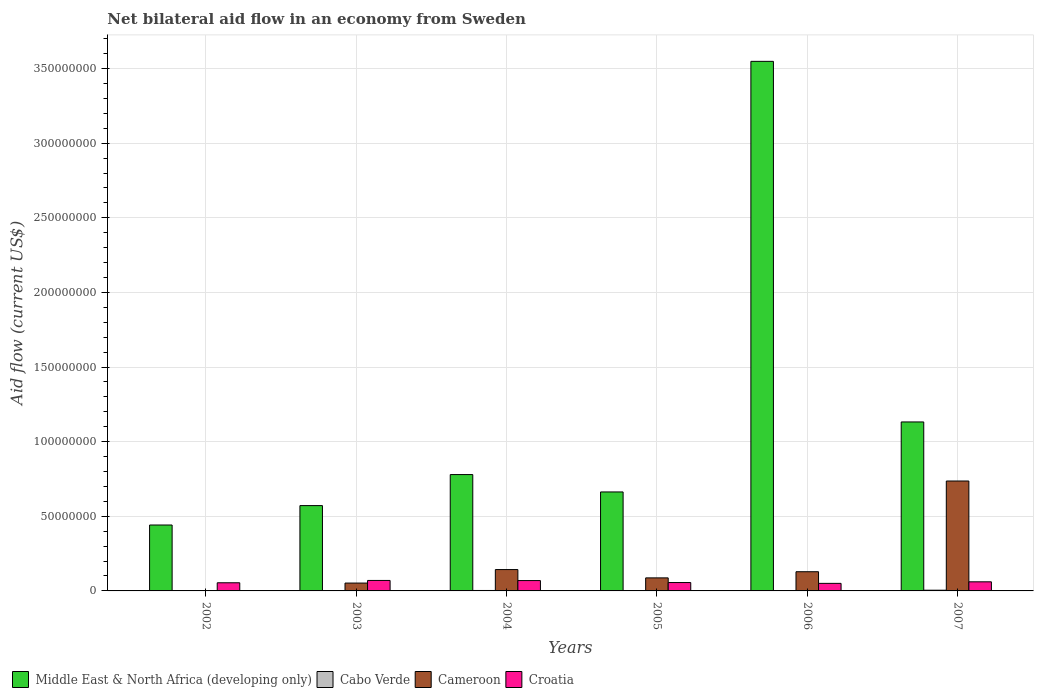How many different coloured bars are there?
Provide a succinct answer. 4. Are the number of bars per tick equal to the number of legend labels?
Provide a succinct answer. Yes. Are the number of bars on each tick of the X-axis equal?
Keep it short and to the point. Yes. What is the net bilateral aid flow in Cameroon in 2002?
Your response must be concise. 2.00e+04. Across all years, what is the maximum net bilateral aid flow in Cameroon?
Provide a succinct answer. 7.36e+07. In which year was the net bilateral aid flow in Croatia maximum?
Give a very brief answer. 2003. In which year was the net bilateral aid flow in Cameroon minimum?
Offer a terse response. 2002. What is the total net bilateral aid flow in Cabo Verde in the graph?
Keep it short and to the point. 1.27e+06. What is the difference between the net bilateral aid flow in Cameroon in 2002 and that in 2006?
Your answer should be very brief. -1.28e+07. What is the difference between the net bilateral aid flow in Middle East & North Africa (developing only) in 2007 and the net bilateral aid flow in Croatia in 2003?
Offer a terse response. 1.06e+08. What is the average net bilateral aid flow in Cabo Verde per year?
Your response must be concise. 2.12e+05. In the year 2002, what is the difference between the net bilateral aid flow in Middle East & North Africa (developing only) and net bilateral aid flow in Cabo Verde?
Keep it short and to the point. 4.41e+07. What is the ratio of the net bilateral aid flow in Middle East & North Africa (developing only) in 2003 to that in 2005?
Your answer should be compact. 0.86. Is the net bilateral aid flow in Cameroon in 2003 less than that in 2006?
Provide a short and direct response. Yes. Is the difference between the net bilateral aid flow in Middle East & North Africa (developing only) in 2002 and 2006 greater than the difference between the net bilateral aid flow in Cabo Verde in 2002 and 2006?
Your answer should be compact. No. What is the difference between the highest and the second highest net bilateral aid flow in Cameroon?
Keep it short and to the point. 5.93e+07. What is the difference between the highest and the lowest net bilateral aid flow in Croatia?
Provide a succinct answer. 1.96e+06. In how many years, is the net bilateral aid flow in Croatia greater than the average net bilateral aid flow in Croatia taken over all years?
Make the answer very short. 3. Is it the case that in every year, the sum of the net bilateral aid flow in Middle East & North Africa (developing only) and net bilateral aid flow in Cabo Verde is greater than the sum of net bilateral aid flow in Croatia and net bilateral aid flow in Cameroon?
Provide a short and direct response. Yes. What does the 3rd bar from the left in 2004 represents?
Offer a very short reply. Cameroon. What does the 3rd bar from the right in 2004 represents?
Your answer should be compact. Cabo Verde. How many bars are there?
Provide a short and direct response. 24. How many years are there in the graph?
Give a very brief answer. 6. Are the values on the major ticks of Y-axis written in scientific E-notation?
Provide a succinct answer. No. Does the graph contain any zero values?
Provide a short and direct response. No. Does the graph contain grids?
Make the answer very short. Yes. How many legend labels are there?
Your response must be concise. 4. How are the legend labels stacked?
Offer a terse response. Horizontal. What is the title of the graph?
Provide a succinct answer. Net bilateral aid flow in an economy from Sweden. What is the label or title of the Y-axis?
Offer a very short reply. Aid flow (current US$). What is the Aid flow (current US$) of Middle East & North Africa (developing only) in 2002?
Ensure brevity in your answer.  4.42e+07. What is the Aid flow (current US$) of Cabo Verde in 2002?
Make the answer very short. 6.00e+04. What is the Aid flow (current US$) in Cameroon in 2002?
Offer a terse response. 2.00e+04. What is the Aid flow (current US$) in Croatia in 2002?
Make the answer very short. 5.46e+06. What is the Aid flow (current US$) of Middle East & North Africa (developing only) in 2003?
Give a very brief answer. 5.72e+07. What is the Aid flow (current US$) in Cameroon in 2003?
Offer a very short reply. 5.26e+06. What is the Aid flow (current US$) of Croatia in 2003?
Your response must be concise. 7.02e+06. What is the Aid flow (current US$) in Middle East & North Africa (developing only) in 2004?
Keep it short and to the point. 7.80e+07. What is the Aid flow (current US$) in Cameroon in 2004?
Ensure brevity in your answer.  1.43e+07. What is the Aid flow (current US$) of Croatia in 2004?
Your answer should be compact. 6.93e+06. What is the Aid flow (current US$) in Middle East & North Africa (developing only) in 2005?
Offer a terse response. 6.63e+07. What is the Aid flow (current US$) in Cabo Verde in 2005?
Give a very brief answer. 2.00e+05. What is the Aid flow (current US$) in Cameroon in 2005?
Make the answer very short. 8.74e+06. What is the Aid flow (current US$) of Croatia in 2005?
Offer a very short reply. 5.62e+06. What is the Aid flow (current US$) of Middle East & North Africa (developing only) in 2006?
Offer a very short reply. 3.55e+08. What is the Aid flow (current US$) of Cabo Verde in 2006?
Your answer should be very brief. 1.50e+05. What is the Aid flow (current US$) of Cameroon in 2006?
Your answer should be compact. 1.29e+07. What is the Aid flow (current US$) of Croatia in 2006?
Ensure brevity in your answer.  5.06e+06. What is the Aid flow (current US$) in Middle East & North Africa (developing only) in 2007?
Offer a terse response. 1.13e+08. What is the Aid flow (current US$) in Cabo Verde in 2007?
Make the answer very short. 4.80e+05. What is the Aid flow (current US$) of Cameroon in 2007?
Offer a terse response. 7.36e+07. What is the Aid flow (current US$) of Croatia in 2007?
Make the answer very short. 6.10e+06. Across all years, what is the maximum Aid flow (current US$) of Middle East & North Africa (developing only)?
Offer a very short reply. 3.55e+08. Across all years, what is the maximum Aid flow (current US$) in Cabo Verde?
Make the answer very short. 4.80e+05. Across all years, what is the maximum Aid flow (current US$) in Cameroon?
Your answer should be very brief. 7.36e+07. Across all years, what is the maximum Aid flow (current US$) in Croatia?
Your answer should be very brief. 7.02e+06. Across all years, what is the minimum Aid flow (current US$) of Middle East & North Africa (developing only)?
Ensure brevity in your answer.  4.42e+07. Across all years, what is the minimum Aid flow (current US$) of Cabo Verde?
Your answer should be very brief. 6.00e+04. Across all years, what is the minimum Aid flow (current US$) of Croatia?
Provide a succinct answer. 5.06e+06. What is the total Aid flow (current US$) in Middle East & North Africa (developing only) in the graph?
Your answer should be compact. 7.14e+08. What is the total Aid flow (current US$) of Cabo Verde in the graph?
Provide a short and direct response. 1.27e+06. What is the total Aid flow (current US$) in Cameroon in the graph?
Make the answer very short. 1.15e+08. What is the total Aid flow (current US$) in Croatia in the graph?
Make the answer very short. 3.62e+07. What is the difference between the Aid flow (current US$) of Middle East & North Africa (developing only) in 2002 and that in 2003?
Offer a very short reply. -1.30e+07. What is the difference between the Aid flow (current US$) of Cabo Verde in 2002 and that in 2003?
Give a very brief answer. -2.00e+04. What is the difference between the Aid flow (current US$) of Cameroon in 2002 and that in 2003?
Offer a very short reply. -5.24e+06. What is the difference between the Aid flow (current US$) of Croatia in 2002 and that in 2003?
Ensure brevity in your answer.  -1.56e+06. What is the difference between the Aid flow (current US$) in Middle East & North Africa (developing only) in 2002 and that in 2004?
Ensure brevity in your answer.  -3.38e+07. What is the difference between the Aid flow (current US$) in Cameroon in 2002 and that in 2004?
Ensure brevity in your answer.  -1.43e+07. What is the difference between the Aid flow (current US$) of Croatia in 2002 and that in 2004?
Make the answer very short. -1.47e+06. What is the difference between the Aid flow (current US$) of Middle East & North Africa (developing only) in 2002 and that in 2005?
Your answer should be very brief. -2.22e+07. What is the difference between the Aid flow (current US$) of Cabo Verde in 2002 and that in 2005?
Make the answer very short. -1.40e+05. What is the difference between the Aid flow (current US$) of Cameroon in 2002 and that in 2005?
Give a very brief answer. -8.72e+06. What is the difference between the Aid flow (current US$) of Middle East & North Africa (developing only) in 2002 and that in 2006?
Offer a very short reply. -3.11e+08. What is the difference between the Aid flow (current US$) of Cabo Verde in 2002 and that in 2006?
Keep it short and to the point. -9.00e+04. What is the difference between the Aid flow (current US$) in Cameroon in 2002 and that in 2006?
Offer a terse response. -1.28e+07. What is the difference between the Aid flow (current US$) of Croatia in 2002 and that in 2006?
Ensure brevity in your answer.  4.00e+05. What is the difference between the Aid flow (current US$) of Middle East & North Africa (developing only) in 2002 and that in 2007?
Your answer should be very brief. -6.90e+07. What is the difference between the Aid flow (current US$) of Cabo Verde in 2002 and that in 2007?
Give a very brief answer. -4.20e+05. What is the difference between the Aid flow (current US$) of Cameroon in 2002 and that in 2007?
Provide a succinct answer. -7.36e+07. What is the difference between the Aid flow (current US$) of Croatia in 2002 and that in 2007?
Provide a succinct answer. -6.40e+05. What is the difference between the Aid flow (current US$) in Middle East & North Africa (developing only) in 2003 and that in 2004?
Your answer should be very brief. -2.08e+07. What is the difference between the Aid flow (current US$) in Cameroon in 2003 and that in 2004?
Provide a short and direct response. -9.05e+06. What is the difference between the Aid flow (current US$) of Middle East & North Africa (developing only) in 2003 and that in 2005?
Your answer should be very brief. -9.15e+06. What is the difference between the Aid flow (current US$) of Cabo Verde in 2003 and that in 2005?
Give a very brief answer. -1.20e+05. What is the difference between the Aid flow (current US$) of Cameroon in 2003 and that in 2005?
Give a very brief answer. -3.48e+06. What is the difference between the Aid flow (current US$) of Croatia in 2003 and that in 2005?
Your answer should be compact. 1.40e+06. What is the difference between the Aid flow (current US$) in Middle East & North Africa (developing only) in 2003 and that in 2006?
Keep it short and to the point. -2.98e+08. What is the difference between the Aid flow (current US$) in Cameroon in 2003 and that in 2006?
Your answer should be compact. -7.60e+06. What is the difference between the Aid flow (current US$) of Croatia in 2003 and that in 2006?
Ensure brevity in your answer.  1.96e+06. What is the difference between the Aid flow (current US$) of Middle East & North Africa (developing only) in 2003 and that in 2007?
Make the answer very short. -5.60e+07. What is the difference between the Aid flow (current US$) in Cabo Verde in 2003 and that in 2007?
Make the answer very short. -4.00e+05. What is the difference between the Aid flow (current US$) in Cameroon in 2003 and that in 2007?
Offer a terse response. -6.84e+07. What is the difference between the Aid flow (current US$) of Croatia in 2003 and that in 2007?
Your response must be concise. 9.20e+05. What is the difference between the Aid flow (current US$) in Middle East & North Africa (developing only) in 2004 and that in 2005?
Your answer should be compact. 1.16e+07. What is the difference between the Aid flow (current US$) of Cabo Verde in 2004 and that in 2005?
Your response must be concise. 1.00e+05. What is the difference between the Aid flow (current US$) in Cameroon in 2004 and that in 2005?
Give a very brief answer. 5.57e+06. What is the difference between the Aid flow (current US$) of Croatia in 2004 and that in 2005?
Provide a short and direct response. 1.31e+06. What is the difference between the Aid flow (current US$) of Middle East & North Africa (developing only) in 2004 and that in 2006?
Provide a succinct answer. -2.77e+08. What is the difference between the Aid flow (current US$) in Cabo Verde in 2004 and that in 2006?
Your answer should be very brief. 1.50e+05. What is the difference between the Aid flow (current US$) in Cameroon in 2004 and that in 2006?
Offer a terse response. 1.45e+06. What is the difference between the Aid flow (current US$) in Croatia in 2004 and that in 2006?
Your answer should be very brief. 1.87e+06. What is the difference between the Aid flow (current US$) of Middle East & North Africa (developing only) in 2004 and that in 2007?
Your answer should be very brief. -3.52e+07. What is the difference between the Aid flow (current US$) of Cameroon in 2004 and that in 2007?
Your answer should be very brief. -5.93e+07. What is the difference between the Aid flow (current US$) in Croatia in 2004 and that in 2007?
Keep it short and to the point. 8.30e+05. What is the difference between the Aid flow (current US$) in Middle East & North Africa (developing only) in 2005 and that in 2006?
Your response must be concise. -2.88e+08. What is the difference between the Aid flow (current US$) of Cameroon in 2005 and that in 2006?
Provide a succinct answer. -4.12e+06. What is the difference between the Aid flow (current US$) of Croatia in 2005 and that in 2006?
Provide a succinct answer. 5.60e+05. What is the difference between the Aid flow (current US$) of Middle East & North Africa (developing only) in 2005 and that in 2007?
Provide a short and direct response. -4.69e+07. What is the difference between the Aid flow (current US$) of Cabo Verde in 2005 and that in 2007?
Provide a succinct answer. -2.80e+05. What is the difference between the Aid flow (current US$) in Cameroon in 2005 and that in 2007?
Keep it short and to the point. -6.49e+07. What is the difference between the Aid flow (current US$) in Croatia in 2005 and that in 2007?
Offer a terse response. -4.80e+05. What is the difference between the Aid flow (current US$) of Middle East & North Africa (developing only) in 2006 and that in 2007?
Your answer should be compact. 2.42e+08. What is the difference between the Aid flow (current US$) of Cabo Verde in 2006 and that in 2007?
Keep it short and to the point. -3.30e+05. What is the difference between the Aid flow (current US$) in Cameroon in 2006 and that in 2007?
Your response must be concise. -6.08e+07. What is the difference between the Aid flow (current US$) of Croatia in 2006 and that in 2007?
Keep it short and to the point. -1.04e+06. What is the difference between the Aid flow (current US$) in Middle East & North Africa (developing only) in 2002 and the Aid flow (current US$) in Cabo Verde in 2003?
Give a very brief answer. 4.41e+07. What is the difference between the Aid flow (current US$) of Middle East & North Africa (developing only) in 2002 and the Aid flow (current US$) of Cameroon in 2003?
Your response must be concise. 3.89e+07. What is the difference between the Aid flow (current US$) of Middle East & North Africa (developing only) in 2002 and the Aid flow (current US$) of Croatia in 2003?
Make the answer very short. 3.71e+07. What is the difference between the Aid flow (current US$) of Cabo Verde in 2002 and the Aid flow (current US$) of Cameroon in 2003?
Provide a succinct answer. -5.20e+06. What is the difference between the Aid flow (current US$) in Cabo Verde in 2002 and the Aid flow (current US$) in Croatia in 2003?
Provide a succinct answer. -6.96e+06. What is the difference between the Aid flow (current US$) in Cameroon in 2002 and the Aid flow (current US$) in Croatia in 2003?
Give a very brief answer. -7.00e+06. What is the difference between the Aid flow (current US$) in Middle East & North Africa (developing only) in 2002 and the Aid flow (current US$) in Cabo Verde in 2004?
Your answer should be compact. 4.39e+07. What is the difference between the Aid flow (current US$) of Middle East & North Africa (developing only) in 2002 and the Aid flow (current US$) of Cameroon in 2004?
Your answer should be very brief. 2.98e+07. What is the difference between the Aid flow (current US$) of Middle East & North Africa (developing only) in 2002 and the Aid flow (current US$) of Croatia in 2004?
Your response must be concise. 3.72e+07. What is the difference between the Aid flow (current US$) in Cabo Verde in 2002 and the Aid flow (current US$) in Cameroon in 2004?
Provide a succinct answer. -1.42e+07. What is the difference between the Aid flow (current US$) of Cabo Verde in 2002 and the Aid flow (current US$) of Croatia in 2004?
Give a very brief answer. -6.87e+06. What is the difference between the Aid flow (current US$) in Cameroon in 2002 and the Aid flow (current US$) in Croatia in 2004?
Make the answer very short. -6.91e+06. What is the difference between the Aid flow (current US$) of Middle East & North Africa (developing only) in 2002 and the Aid flow (current US$) of Cabo Verde in 2005?
Your answer should be very brief. 4.40e+07. What is the difference between the Aid flow (current US$) in Middle East & North Africa (developing only) in 2002 and the Aid flow (current US$) in Cameroon in 2005?
Make the answer very short. 3.54e+07. What is the difference between the Aid flow (current US$) of Middle East & North Africa (developing only) in 2002 and the Aid flow (current US$) of Croatia in 2005?
Ensure brevity in your answer.  3.85e+07. What is the difference between the Aid flow (current US$) in Cabo Verde in 2002 and the Aid flow (current US$) in Cameroon in 2005?
Offer a terse response. -8.68e+06. What is the difference between the Aid flow (current US$) of Cabo Verde in 2002 and the Aid flow (current US$) of Croatia in 2005?
Give a very brief answer. -5.56e+06. What is the difference between the Aid flow (current US$) in Cameroon in 2002 and the Aid flow (current US$) in Croatia in 2005?
Provide a succinct answer. -5.60e+06. What is the difference between the Aid flow (current US$) in Middle East & North Africa (developing only) in 2002 and the Aid flow (current US$) in Cabo Verde in 2006?
Offer a very short reply. 4.40e+07. What is the difference between the Aid flow (current US$) of Middle East & North Africa (developing only) in 2002 and the Aid flow (current US$) of Cameroon in 2006?
Make the answer very short. 3.13e+07. What is the difference between the Aid flow (current US$) of Middle East & North Africa (developing only) in 2002 and the Aid flow (current US$) of Croatia in 2006?
Provide a short and direct response. 3.91e+07. What is the difference between the Aid flow (current US$) of Cabo Verde in 2002 and the Aid flow (current US$) of Cameroon in 2006?
Your answer should be very brief. -1.28e+07. What is the difference between the Aid flow (current US$) of Cabo Verde in 2002 and the Aid flow (current US$) of Croatia in 2006?
Ensure brevity in your answer.  -5.00e+06. What is the difference between the Aid flow (current US$) of Cameroon in 2002 and the Aid flow (current US$) of Croatia in 2006?
Provide a succinct answer. -5.04e+06. What is the difference between the Aid flow (current US$) in Middle East & North Africa (developing only) in 2002 and the Aid flow (current US$) in Cabo Verde in 2007?
Your answer should be very brief. 4.37e+07. What is the difference between the Aid flow (current US$) in Middle East & North Africa (developing only) in 2002 and the Aid flow (current US$) in Cameroon in 2007?
Your answer should be very brief. -2.95e+07. What is the difference between the Aid flow (current US$) of Middle East & North Africa (developing only) in 2002 and the Aid flow (current US$) of Croatia in 2007?
Ensure brevity in your answer.  3.81e+07. What is the difference between the Aid flow (current US$) in Cabo Verde in 2002 and the Aid flow (current US$) in Cameroon in 2007?
Keep it short and to the point. -7.36e+07. What is the difference between the Aid flow (current US$) of Cabo Verde in 2002 and the Aid flow (current US$) of Croatia in 2007?
Offer a terse response. -6.04e+06. What is the difference between the Aid flow (current US$) in Cameroon in 2002 and the Aid flow (current US$) in Croatia in 2007?
Provide a short and direct response. -6.08e+06. What is the difference between the Aid flow (current US$) of Middle East & North Africa (developing only) in 2003 and the Aid flow (current US$) of Cabo Verde in 2004?
Give a very brief answer. 5.69e+07. What is the difference between the Aid flow (current US$) in Middle East & North Africa (developing only) in 2003 and the Aid flow (current US$) in Cameroon in 2004?
Offer a very short reply. 4.28e+07. What is the difference between the Aid flow (current US$) of Middle East & North Africa (developing only) in 2003 and the Aid flow (current US$) of Croatia in 2004?
Your response must be concise. 5.02e+07. What is the difference between the Aid flow (current US$) in Cabo Verde in 2003 and the Aid flow (current US$) in Cameroon in 2004?
Give a very brief answer. -1.42e+07. What is the difference between the Aid flow (current US$) of Cabo Verde in 2003 and the Aid flow (current US$) of Croatia in 2004?
Your answer should be compact. -6.85e+06. What is the difference between the Aid flow (current US$) of Cameroon in 2003 and the Aid flow (current US$) of Croatia in 2004?
Offer a very short reply. -1.67e+06. What is the difference between the Aid flow (current US$) in Middle East & North Africa (developing only) in 2003 and the Aid flow (current US$) in Cabo Verde in 2005?
Give a very brief answer. 5.70e+07. What is the difference between the Aid flow (current US$) of Middle East & North Africa (developing only) in 2003 and the Aid flow (current US$) of Cameroon in 2005?
Give a very brief answer. 4.84e+07. What is the difference between the Aid flow (current US$) of Middle East & North Africa (developing only) in 2003 and the Aid flow (current US$) of Croatia in 2005?
Provide a short and direct response. 5.15e+07. What is the difference between the Aid flow (current US$) in Cabo Verde in 2003 and the Aid flow (current US$) in Cameroon in 2005?
Offer a terse response. -8.66e+06. What is the difference between the Aid flow (current US$) of Cabo Verde in 2003 and the Aid flow (current US$) of Croatia in 2005?
Provide a short and direct response. -5.54e+06. What is the difference between the Aid flow (current US$) in Cameroon in 2003 and the Aid flow (current US$) in Croatia in 2005?
Your response must be concise. -3.60e+05. What is the difference between the Aid flow (current US$) of Middle East & North Africa (developing only) in 2003 and the Aid flow (current US$) of Cabo Verde in 2006?
Keep it short and to the point. 5.70e+07. What is the difference between the Aid flow (current US$) in Middle East & North Africa (developing only) in 2003 and the Aid flow (current US$) in Cameroon in 2006?
Keep it short and to the point. 4.43e+07. What is the difference between the Aid flow (current US$) of Middle East & North Africa (developing only) in 2003 and the Aid flow (current US$) of Croatia in 2006?
Your answer should be very brief. 5.21e+07. What is the difference between the Aid flow (current US$) in Cabo Verde in 2003 and the Aid flow (current US$) in Cameroon in 2006?
Provide a succinct answer. -1.28e+07. What is the difference between the Aid flow (current US$) of Cabo Verde in 2003 and the Aid flow (current US$) of Croatia in 2006?
Make the answer very short. -4.98e+06. What is the difference between the Aid flow (current US$) of Middle East & North Africa (developing only) in 2003 and the Aid flow (current US$) of Cabo Verde in 2007?
Provide a succinct answer. 5.67e+07. What is the difference between the Aid flow (current US$) of Middle East & North Africa (developing only) in 2003 and the Aid flow (current US$) of Cameroon in 2007?
Provide a succinct answer. -1.65e+07. What is the difference between the Aid flow (current US$) of Middle East & North Africa (developing only) in 2003 and the Aid flow (current US$) of Croatia in 2007?
Make the answer very short. 5.11e+07. What is the difference between the Aid flow (current US$) of Cabo Verde in 2003 and the Aid flow (current US$) of Cameroon in 2007?
Keep it short and to the point. -7.36e+07. What is the difference between the Aid flow (current US$) in Cabo Verde in 2003 and the Aid flow (current US$) in Croatia in 2007?
Offer a terse response. -6.02e+06. What is the difference between the Aid flow (current US$) in Cameroon in 2003 and the Aid flow (current US$) in Croatia in 2007?
Ensure brevity in your answer.  -8.40e+05. What is the difference between the Aid flow (current US$) in Middle East & North Africa (developing only) in 2004 and the Aid flow (current US$) in Cabo Verde in 2005?
Offer a very short reply. 7.78e+07. What is the difference between the Aid flow (current US$) of Middle East & North Africa (developing only) in 2004 and the Aid flow (current US$) of Cameroon in 2005?
Make the answer very short. 6.92e+07. What is the difference between the Aid flow (current US$) of Middle East & North Africa (developing only) in 2004 and the Aid flow (current US$) of Croatia in 2005?
Make the answer very short. 7.23e+07. What is the difference between the Aid flow (current US$) of Cabo Verde in 2004 and the Aid flow (current US$) of Cameroon in 2005?
Offer a terse response. -8.44e+06. What is the difference between the Aid flow (current US$) of Cabo Verde in 2004 and the Aid flow (current US$) of Croatia in 2005?
Give a very brief answer. -5.32e+06. What is the difference between the Aid flow (current US$) in Cameroon in 2004 and the Aid flow (current US$) in Croatia in 2005?
Offer a terse response. 8.69e+06. What is the difference between the Aid flow (current US$) in Middle East & North Africa (developing only) in 2004 and the Aid flow (current US$) in Cabo Verde in 2006?
Offer a terse response. 7.78e+07. What is the difference between the Aid flow (current US$) in Middle East & North Africa (developing only) in 2004 and the Aid flow (current US$) in Cameroon in 2006?
Make the answer very short. 6.51e+07. What is the difference between the Aid flow (current US$) of Middle East & North Africa (developing only) in 2004 and the Aid flow (current US$) of Croatia in 2006?
Make the answer very short. 7.29e+07. What is the difference between the Aid flow (current US$) in Cabo Verde in 2004 and the Aid flow (current US$) in Cameroon in 2006?
Provide a succinct answer. -1.26e+07. What is the difference between the Aid flow (current US$) in Cabo Verde in 2004 and the Aid flow (current US$) in Croatia in 2006?
Your answer should be compact. -4.76e+06. What is the difference between the Aid flow (current US$) in Cameroon in 2004 and the Aid flow (current US$) in Croatia in 2006?
Your answer should be very brief. 9.25e+06. What is the difference between the Aid flow (current US$) in Middle East & North Africa (developing only) in 2004 and the Aid flow (current US$) in Cabo Verde in 2007?
Your answer should be very brief. 7.75e+07. What is the difference between the Aid flow (current US$) in Middle East & North Africa (developing only) in 2004 and the Aid flow (current US$) in Cameroon in 2007?
Offer a very short reply. 4.32e+06. What is the difference between the Aid flow (current US$) in Middle East & North Africa (developing only) in 2004 and the Aid flow (current US$) in Croatia in 2007?
Ensure brevity in your answer.  7.19e+07. What is the difference between the Aid flow (current US$) in Cabo Verde in 2004 and the Aid flow (current US$) in Cameroon in 2007?
Make the answer very short. -7.33e+07. What is the difference between the Aid flow (current US$) in Cabo Verde in 2004 and the Aid flow (current US$) in Croatia in 2007?
Provide a succinct answer. -5.80e+06. What is the difference between the Aid flow (current US$) in Cameroon in 2004 and the Aid flow (current US$) in Croatia in 2007?
Ensure brevity in your answer.  8.21e+06. What is the difference between the Aid flow (current US$) of Middle East & North Africa (developing only) in 2005 and the Aid flow (current US$) of Cabo Verde in 2006?
Give a very brief answer. 6.62e+07. What is the difference between the Aid flow (current US$) of Middle East & North Africa (developing only) in 2005 and the Aid flow (current US$) of Cameroon in 2006?
Make the answer very short. 5.34e+07. What is the difference between the Aid flow (current US$) of Middle East & North Africa (developing only) in 2005 and the Aid flow (current US$) of Croatia in 2006?
Offer a terse response. 6.12e+07. What is the difference between the Aid flow (current US$) of Cabo Verde in 2005 and the Aid flow (current US$) of Cameroon in 2006?
Provide a succinct answer. -1.27e+07. What is the difference between the Aid flow (current US$) of Cabo Verde in 2005 and the Aid flow (current US$) of Croatia in 2006?
Keep it short and to the point. -4.86e+06. What is the difference between the Aid flow (current US$) of Cameroon in 2005 and the Aid flow (current US$) of Croatia in 2006?
Offer a very short reply. 3.68e+06. What is the difference between the Aid flow (current US$) in Middle East & North Africa (developing only) in 2005 and the Aid flow (current US$) in Cabo Verde in 2007?
Offer a terse response. 6.58e+07. What is the difference between the Aid flow (current US$) of Middle East & North Africa (developing only) in 2005 and the Aid flow (current US$) of Cameroon in 2007?
Your answer should be very brief. -7.33e+06. What is the difference between the Aid flow (current US$) of Middle East & North Africa (developing only) in 2005 and the Aid flow (current US$) of Croatia in 2007?
Your answer should be very brief. 6.02e+07. What is the difference between the Aid flow (current US$) of Cabo Verde in 2005 and the Aid flow (current US$) of Cameroon in 2007?
Make the answer very short. -7.34e+07. What is the difference between the Aid flow (current US$) in Cabo Verde in 2005 and the Aid flow (current US$) in Croatia in 2007?
Your answer should be very brief. -5.90e+06. What is the difference between the Aid flow (current US$) of Cameroon in 2005 and the Aid flow (current US$) of Croatia in 2007?
Give a very brief answer. 2.64e+06. What is the difference between the Aid flow (current US$) in Middle East & North Africa (developing only) in 2006 and the Aid flow (current US$) in Cabo Verde in 2007?
Keep it short and to the point. 3.54e+08. What is the difference between the Aid flow (current US$) of Middle East & North Africa (developing only) in 2006 and the Aid flow (current US$) of Cameroon in 2007?
Provide a succinct answer. 2.81e+08. What is the difference between the Aid flow (current US$) of Middle East & North Africa (developing only) in 2006 and the Aid flow (current US$) of Croatia in 2007?
Ensure brevity in your answer.  3.49e+08. What is the difference between the Aid flow (current US$) in Cabo Verde in 2006 and the Aid flow (current US$) in Cameroon in 2007?
Ensure brevity in your answer.  -7.35e+07. What is the difference between the Aid flow (current US$) of Cabo Verde in 2006 and the Aid flow (current US$) of Croatia in 2007?
Ensure brevity in your answer.  -5.95e+06. What is the difference between the Aid flow (current US$) in Cameroon in 2006 and the Aid flow (current US$) in Croatia in 2007?
Make the answer very short. 6.76e+06. What is the average Aid flow (current US$) of Middle East & North Africa (developing only) per year?
Your response must be concise. 1.19e+08. What is the average Aid flow (current US$) of Cabo Verde per year?
Make the answer very short. 2.12e+05. What is the average Aid flow (current US$) of Cameroon per year?
Offer a very short reply. 1.91e+07. What is the average Aid flow (current US$) in Croatia per year?
Make the answer very short. 6.03e+06. In the year 2002, what is the difference between the Aid flow (current US$) in Middle East & North Africa (developing only) and Aid flow (current US$) in Cabo Verde?
Provide a short and direct response. 4.41e+07. In the year 2002, what is the difference between the Aid flow (current US$) in Middle East & North Africa (developing only) and Aid flow (current US$) in Cameroon?
Provide a short and direct response. 4.41e+07. In the year 2002, what is the difference between the Aid flow (current US$) of Middle East & North Africa (developing only) and Aid flow (current US$) of Croatia?
Offer a terse response. 3.87e+07. In the year 2002, what is the difference between the Aid flow (current US$) in Cabo Verde and Aid flow (current US$) in Cameroon?
Your answer should be very brief. 4.00e+04. In the year 2002, what is the difference between the Aid flow (current US$) of Cabo Verde and Aid flow (current US$) of Croatia?
Provide a succinct answer. -5.40e+06. In the year 2002, what is the difference between the Aid flow (current US$) of Cameroon and Aid flow (current US$) of Croatia?
Provide a short and direct response. -5.44e+06. In the year 2003, what is the difference between the Aid flow (current US$) in Middle East & North Africa (developing only) and Aid flow (current US$) in Cabo Verde?
Your answer should be very brief. 5.71e+07. In the year 2003, what is the difference between the Aid flow (current US$) in Middle East & North Africa (developing only) and Aid flow (current US$) in Cameroon?
Offer a very short reply. 5.19e+07. In the year 2003, what is the difference between the Aid flow (current US$) in Middle East & North Africa (developing only) and Aid flow (current US$) in Croatia?
Keep it short and to the point. 5.01e+07. In the year 2003, what is the difference between the Aid flow (current US$) in Cabo Verde and Aid flow (current US$) in Cameroon?
Your answer should be compact. -5.18e+06. In the year 2003, what is the difference between the Aid flow (current US$) of Cabo Verde and Aid flow (current US$) of Croatia?
Your response must be concise. -6.94e+06. In the year 2003, what is the difference between the Aid flow (current US$) of Cameroon and Aid flow (current US$) of Croatia?
Your response must be concise. -1.76e+06. In the year 2004, what is the difference between the Aid flow (current US$) of Middle East & North Africa (developing only) and Aid flow (current US$) of Cabo Verde?
Provide a succinct answer. 7.77e+07. In the year 2004, what is the difference between the Aid flow (current US$) of Middle East & North Africa (developing only) and Aid flow (current US$) of Cameroon?
Provide a succinct answer. 6.36e+07. In the year 2004, what is the difference between the Aid flow (current US$) in Middle East & North Africa (developing only) and Aid flow (current US$) in Croatia?
Offer a very short reply. 7.10e+07. In the year 2004, what is the difference between the Aid flow (current US$) in Cabo Verde and Aid flow (current US$) in Cameroon?
Your answer should be compact. -1.40e+07. In the year 2004, what is the difference between the Aid flow (current US$) of Cabo Verde and Aid flow (current US$) of Croatia?
Your answer should be very brief. -6.63e+06. In the year 2004, what is the difference between the Aid flow (current US$) in Cameroon and Aid flow (current US$) in Croatia?
Your answer should be very brief. 7.38e+06. In the year 2005, what is the difference between the Aid flow (current US$) of Middle East & North Africa (developing only) and Aid flow (current US$) of Cabo Verde?
Make the answer very short. 6.61e+07. In the year 2005, what is the difference between the Aid flow (current US$) of Middle East & North Africa (developing only) and Aid flow (current US$) of Cameroon?
Give a very brief answer. 5.76e+07. In the year 2005, what is the difference between the Aid flow (current US$) of Middle East & North Africa (developing only) and Aid flow (current US$) of Croatia?
Offer a terse response. 6.07e+07. In the year 2005, what is the difference between the Aid flow (current US$) in Cabo Verde and Aid flow (current US$) in Cameroon?
Your answer should be compact. -8.54e+06. In the year 2005, what is the difference between the Aid flow (current US$) in Cabo Verde and Aid flow (current US$) in Croatia?
Your answer should be compact. -5.42e+06. In the year 2005, what is the difference between the Aid flow (current US$) of Cameroon and Aid flow (current US$) of Croatia?
Your answer should be very brief. 3.12e+06. In the year 2006, what is the difference between the Aid flow (current US$) in Middle East & North Africa (developing only) and Aid flow (current US$) in Cabo Verde?
Your answer should be very brief. 3.55e+08. In the year 2006, what is the difference between the Aid flow (current US$) in Middle East & North Africa (developing only) and Aid flow (current US$) in Cameroon?
Provide a succinct answer. 3.42e+08. In the year 2006, what is the difference between the Aid flow (current US$) of Middle East & North Africa (developing only) and Aid flow (current US$) of Croatia?
Ensure brevity in your answer.  3.50e+08. In the year 2006, what is the difference between the Aid flow (current US$) in Cabo Verde and Aid flow (current US$) in Cameroon?
Provide a short and direct response. -1.27e+07. In the year 2006, what is the difference between the Aid flow (current US$) in Cabo Verde and Aid flow (current US$) in Croatia?
Your response must be concise. -4.91e+06. In the year 2006, what is the difference between the Aid flow (current US$) of Cameroon and Aid flow (current US$) of Croatia?
Your answer should be very brief. 7.80e+06. In the year 2007, what is the difference between the Aid flow (current US$) in Middle East & North Africa (developing only) and Aid flow (current US$) in Cabo Verde?
Your answer should be very brief. 1.13e+08. In the year 2007, what is the difference between the Aid flow (current US$) of Middle East & North Africa (developing only) and Aid flow (current US$) of Cameroon?
Provide a short and direct response. 3.96e+07. In the year 2007, what is the difference between the Aid flow (current US$) of Middle East & North Africa (developing only) and Aid flow (current US$) of Croatia?
Provide a short and direct response. 1.07e+08. In the year 2007, what is the difference between the Aid flow (current US$) of Cabo Verde and Aid flow (current US$) of Cameroon?
Provide a succinct answer. -7.32e+07. In the year 2007, what is the difference between the Aid flow (current US$) of Cabo Verde and Aid flow (current US$) of Croatia?
Offer a very short reply. -5.62e+06. In the year 2007, what is the difference between the Aid flow (current US$) of Cameroon and Aid flow (current US$) of Croatia?
Make the answer very short. 6.75e+07. What is the ratio of the Aid flow (current US$) of Middle East & North Africa (developing only) in 2002 to that in 2003?
Your answer should be very brief. 0.77. What is the ratio of the Aid flow (current US$) of Cabo Verde in 2002 to that in 2003?
Your response must be concise. 0.75. What is the ratio of the Aid flow (current US$) in Cameroon in 2002 to that in 2003?
Keep it short and to the point. 0. What is the ratio of the Aid flow (current US$) in Croatia in 2002 to that in 2003?
Offer a terse response. 0.78. What is the ratio of the Aid flow (current US$) in Middle East & North Africa (developing only) in 2002 to that in 2004?
Your response must be concise. 0.57. What is the ratio of the Aid flow (current US$) in Cabo Verde in 2002 to that in 2004?
Offer a terse response. 0.2. What is the ratio of the Aid flow (current US$) in Cameroon in 2002 to that in 2004?
Offer a terse response. 0. What is the ratio of the Aid flow (current US$) of Croatia in 2002 to that in 2004?
Offer a terse response. 0.79. What is the ratio of the Aid flow (current US$) in Middle East & North Africa (developing only) in 2002 to that in 2005?
Give a very brief answer. 0.67. What is the ratio of the Aid flow (current US$) in Cabo Verde in 2002 to that in 2005?
Provide a short and direct response. 0.3. What is the ratio of the Aid flow (current US$) of Cameroon in 2002 to that in 2005?
Ensure brevity in your answer.  0. What is the ratio of the Aid flow (current US$) in Croatia in 2002 to that in 2005?
Offer a terse response. 0.97. What is the ratio of the Aid flow (current US$) of Middle East & North Africa (developing only) in 2002 to that in 2006?
Keep it short and to the point. 0.12. What is the ratio of the Aid flow (current US$) of Cabo Verde in 2002 to that in 2006?
Make the answer very short. 0.4. What is the ratio of the Aid flow (current US$) of Cameroon in 2002 to that in 2006?
Provide a short and direct response. 0. What is the ratio of the Aid flow (current US$) in Croatia in 2002 to that in 2006?
Your answer should be compact. 1.08. What is the ratio of the Aid flow (current US$) in Middle East & North Africa (developing only) in 2002 to that in 2007?
Keep it short and to the point. 0.39. What is the ratio of the Aid flow (current US$) of Cabo Verde in 2002 to that in 2007?
Your answer should be compact. 0.12. What is the ratio of the Aid flow (current US$) in Cameroon in 2002 to that in 2007?
Give a very brief answer. 0. What is the ratio of the Aid flow (current US$) in Croatia in 2002 to that in 2007?
Your response must be concise. 0.9. What is the ratio of the Aid flow (current US$) of Middle East & North Africa (developing only) in 2003 to that in 2004?
Make the answer very short. 0.73. What is the ratio of the Aid flow (current US$) of Cabo Verde in 2003 to that in 2004?
Offer a very short reply. 0.27. What is the ratio of the Aid flow (current US$) of Cameroon in 2003 to that in 2004?
Provide a short and direct response. 0.37. What is the ratio of the Aid flow (current US$) of Croatia in 2003 to that in 2004?
Your answer should be compact. 1.01. What is the ratio of the Aid flow (current US$) in Middle East & North Africa (developing only) in 2003 to that in 2005?
Keep it short and to the point. 0.86. What is the ratio of the Aid flow (current US$) of Cameroon in 2003 to that in 2005?
Give a very brief answer. 0.6. What is the ratio of the Aid flow (current US$) of Croatia in 2003 to that in 2005?
Offer a very short reply. 1.25. What is the ratio of the Aid flow (current US$) of Middle East & North Africa (developing only) in 2003 to that in 2006?
Provide a short and direct response. 0.16. What is the ratio of the Aid flow (current US$) in Cabo Verde in 2003 to that in 2006?
Your response must be concise. 0.53. What is the ratio of the Aid flow (current US$) of Cameroon in 2003 to that in 2006?
Your answer should be very brief. 0.41. What is the ratio of the Aid flow (current US$) of Croatia in 2003 to that in 2006?
Your answer should be compact. 1.39. What is the ratio of the Aid flow (current US$) of Middle East & North Africa (developing only) in 2003 to that in 2007?
Ensure brevity in your answer.  0.5. What is the ratio of the Aid flow (current US$) in Cabo Verde in 2003 to that in 2007?
Your response must be concise. 0.17. What is the ratio of the Aid flow (current US$) in Cameroon in 2003 to that in 2007?
Your answer should be compact. 0.07. What is the ratio of the Aid flow (current US$) of Croatia in 2003 to that in 2007?
Provide a succinct answer. 1.15. What is the ratio of the Aid flow (current US$) in Middle East & North Africa (developing only) in 2004 to that in 2005?
Give a very brief answer. 1.18. What is the ratio of the Aid flow (current US$) of Cameroon in 2004 to that in 2005?
Make the answer very short. 1.64. What is the ratio of the Aid flow (current US$) in Croatia in 2004 to that in 2005?
Provide a short and direct response. 1.23. What is the ratio of the Aid flow (current US$) of Middle East & North Africa (developing only) in 2004 to that in 2006?
Give a very brief answer. 0.22. What is the ratio of the Aid flow (current US$) in Cabo Verde in 2004 to that in 2006?
Provide a short and direct response. 2. What is the ratio of the Aid flow (current US$) of Cameroon in 2004 to that in 2006?
Ensure brevity in your answer.  1.11. What is the ratio of the Aid flow (current US$) of Croatia in 2004 to that in 2006?
Your answer should be very brief. 1.37. What is the ratio of the Aid flow (current US$) of Middle East & North Africa (developing only) in 2004 to that in 2007?
Keep it short and to the point. 0.69. What is the ratio of the Aid flow (current US$) of Cameroon in 2004 to that in 2007?
Your answer should be very brief. 0.19. What is the ratio of the Aid flow (current US$) in Croatia in 2004 to that in 2007?
Give a very brief answer. 1.14. What is the ratio of the Aid flow (current US$) of Middle East & North Africa (developing only) in 2005 to that in 2006?
Your answer should be compact. 0.19. What is the ratio of the Aid flow (current US$) in Cabo Verde in 2005 to that in 2006?
Offer a terse response. 1.33. What is the ratio of the Aid flow (current US$) of Cameroon in 2005 to that in 2006?
Provide a short and direct response. 0.68. What is the ratio of the Aid flow (current US$) in Croatia in 2005 to that in 2006?
Offer a very short reply. 1.11. What is the ratio of the Aid flow (current US$) of Middle East & North Africa (developing only) in 2005 to that in 2007?
Offer a terse response. 0.59. What is the ratio of the Aid flow (current US$) in Cabo Verde in 2005 to that in 2007?
Offer a terse response. 0.42. What is the ratio of the Aid flow (current US$) of Cameroon in 2005 to that in 2007?
Provide a short and direct response. 0.12. What is the ratio of the Aid flow (current US$) in Croatia in 2005 to that in 2007?
Offer a very short reply. 0.92. What is the ratio of the Aid flow (current US$) in Middle East & North Africa (developing only) in 2006 to that in 2007?
Offer a terse response. 3.13. What is the ratio of the Aid flow (current US$) of Cabo Verde in 2006 to that in 2007?
Keep it short and to the point. 0.31. What is the ratio of the Aid flow (current US$) in Cameroon in 2006 to that in 2007?
Provide a succinct answer. 0.17. What is the ratio of the Aid flow (current US$) in Croatia in 2006 to that in 2007?
Your response must be concise. 0.83. What is the difference between the highest and the second highest Aid flow (current US$) in Middle East & North Africa (developing only)?
Your response must be concise. 2.42e+08. What is the difference between the highest and the second highest Aid flow (current US$) of Cameroon?
Offer a terse response. 5.93e+07. What is the difference between the highest and the second highest Aid flow (current US$) in Croatia?
Provide a short and direct response. 9.00e+04. What is the difference between the highest and the lowest Aid flow (current US$) of Middle East & North Africa (developing only)?
Offer a very short reply. 3.11e+08. What is the difference between the highest and the lowest Aid flow (current US$) of Cabo Verde?
Offer a very short reply. 4.20e+05. What is the difference between the highest and the lowest Aid flow (current US$) in Cameroon?
Keep it short and to the point. 7.36e+07. What is the difference between the highest and the lowest Aid flow (current US$) in Croatia?
Your answer should be very brief. 1.96e+06. 